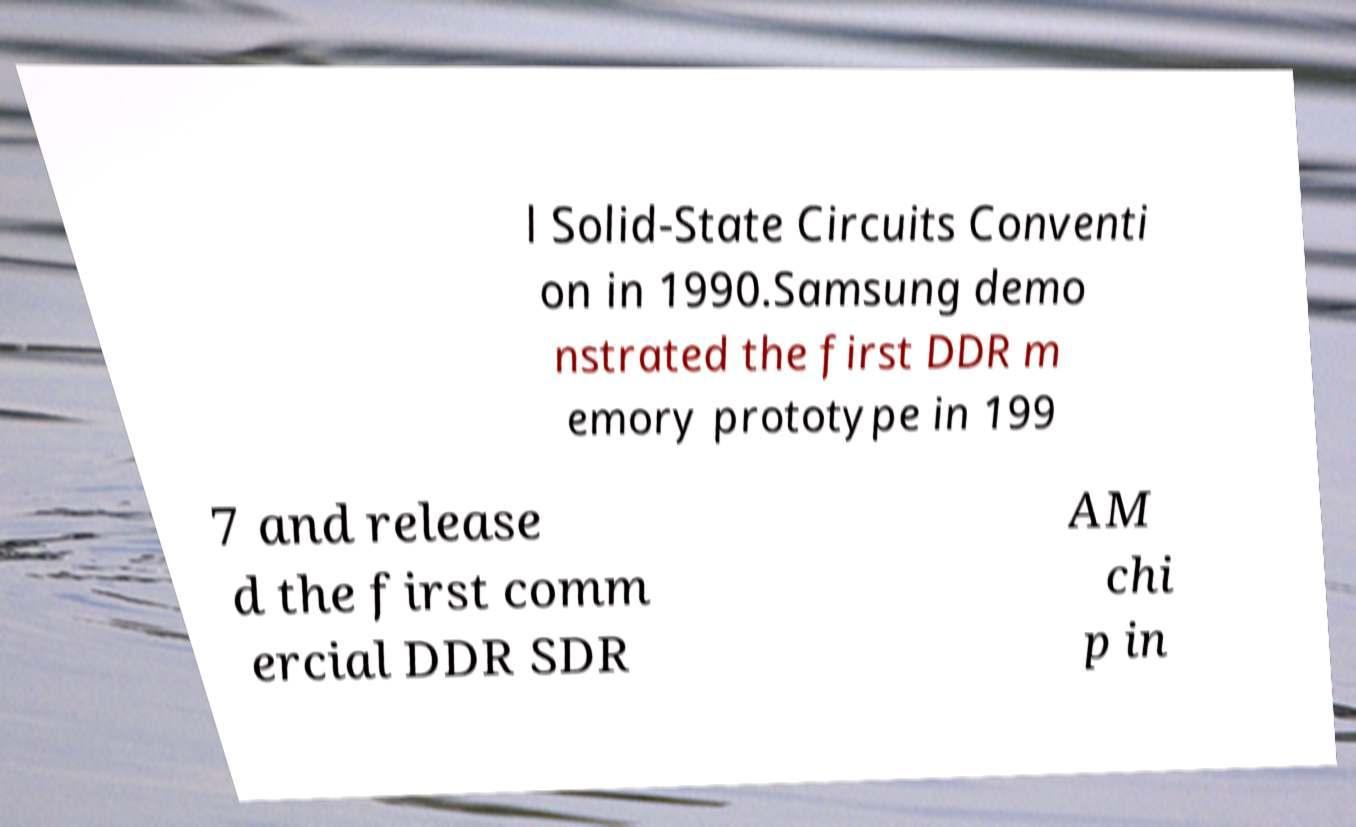Please read and relay the text visible in this image. What does it say? l Solid-State Circuits Conventi on in 1990.Samsung demo nstrated the first DDR m emory prototype in 199 7 and release d the first comm ercial DDR SDR AM chi p in 